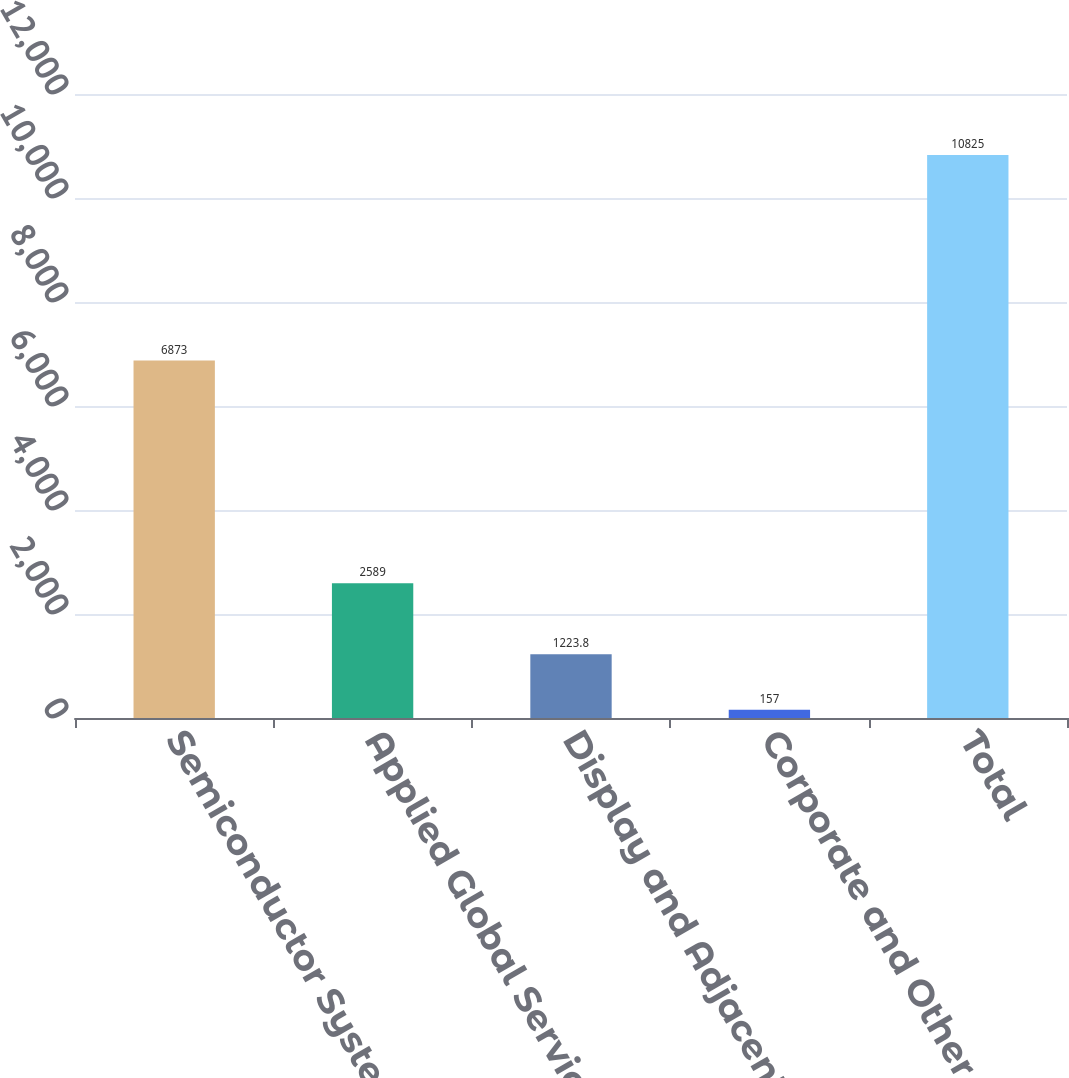Convert chart to OTSL. <chart><loc_0><loc_0><loc_500><loc_500><bar_chart><fcel>Semiconductor Systems<fcel>Applied Global Services<fcel>Display and Adjacent Markets<fcel>Corporate and Other<fcel>Total<nl><fcel>6873<fcel>2589<fcel>1223.8<fcel>157<fcel>10825<nl></chart> 